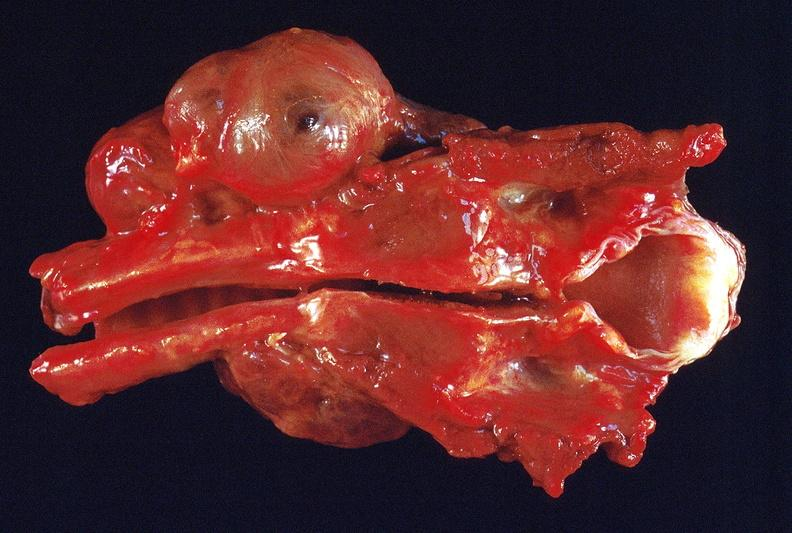where does this belong to?
Answer the question using a single word or phrase. Endocrine system 